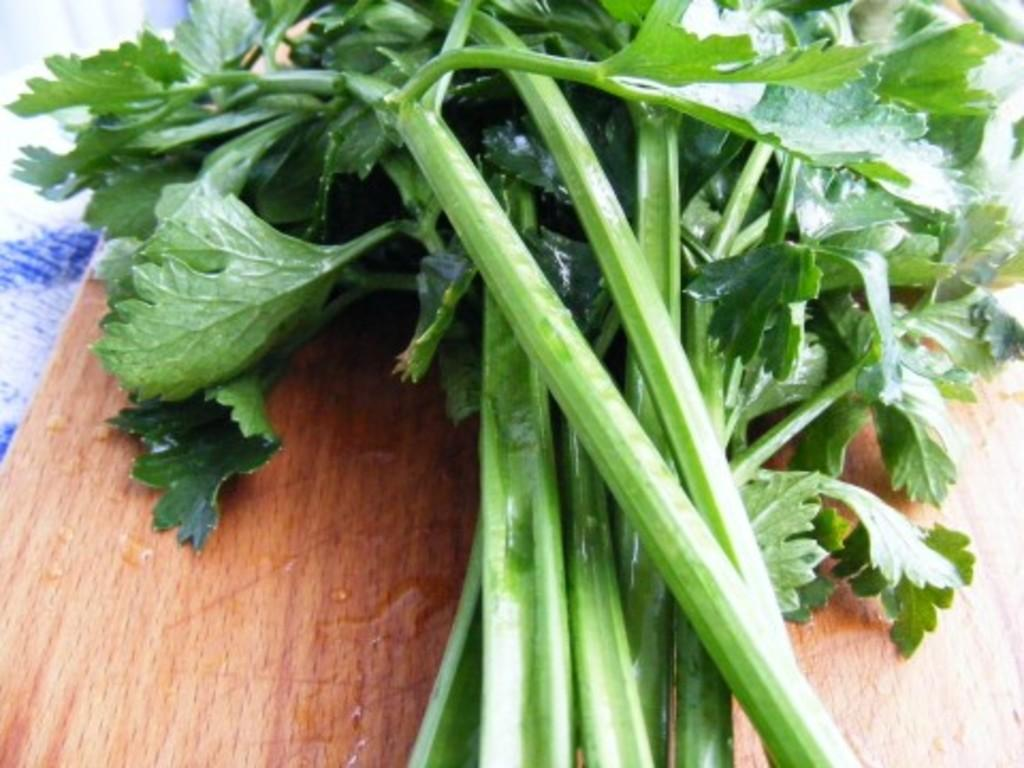What type of vegetables can be seen in the image? There are green leafy vegetables in the image. On what surface are the vegetables placed? The vegetables are placed on a wooden surface. Can you describe any other objects or elements in the image? There is a napkin at the left side of the image. Reasoning: Let' Let's think step by step in order to produce the conversation. We start by identifying the main subject in the image, which is the green leafy vegetables. Then, we describe the surface on which the vegetables are placed, which is a wooden surface. Finally, we mention any other objects or elements present in the image, which is a napkin at the left side. Absurd Question/Answer: What type of store can be seen in the background of the image? There is no store visible in the image; it only shows green leafy vegetables on a wooden surface and a napkin at the left side. 